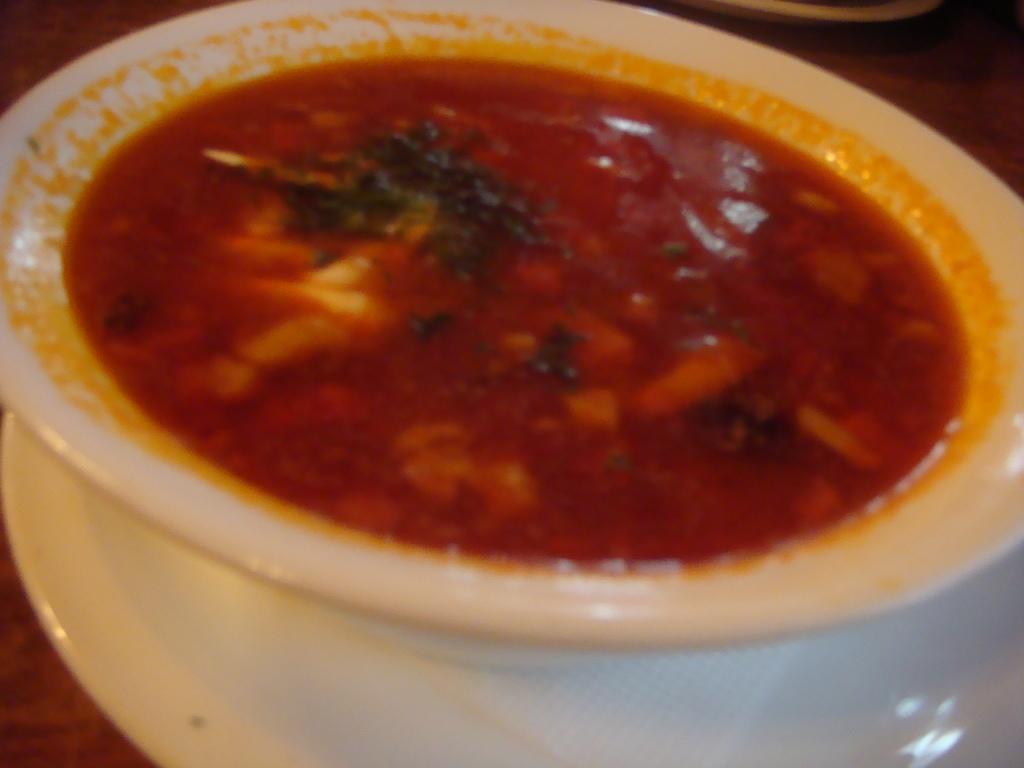Please provide a concise description of this image. In this image I can see a bowl which consists of some food item. This is placed on a table. 